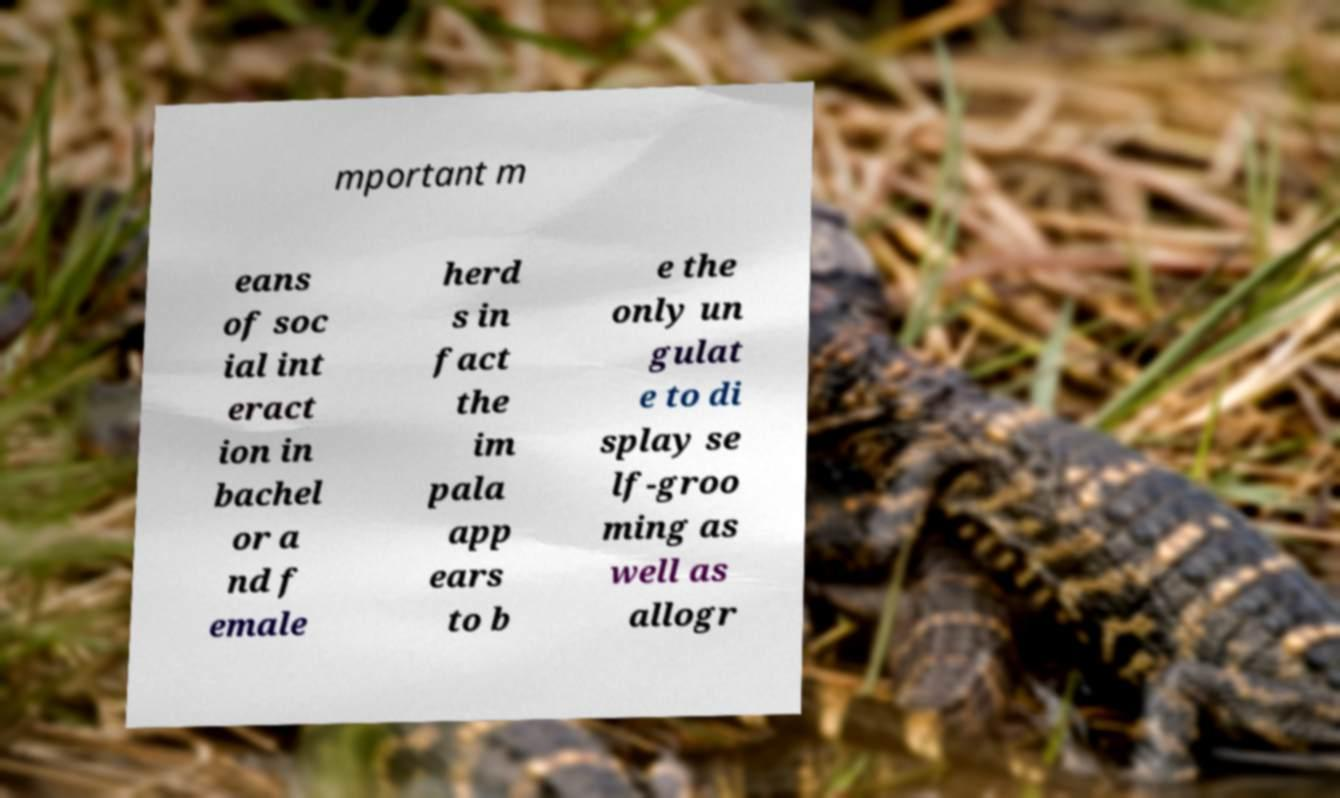Could you assist in decoding the text presented in this image and type it out clearly? mportant m eans of soc ial int eract ion in bachel or a nd f emale herd s in fact the im pala app ears to b e the only un gulat e to di splay se lf-groo ming as well as allogr 